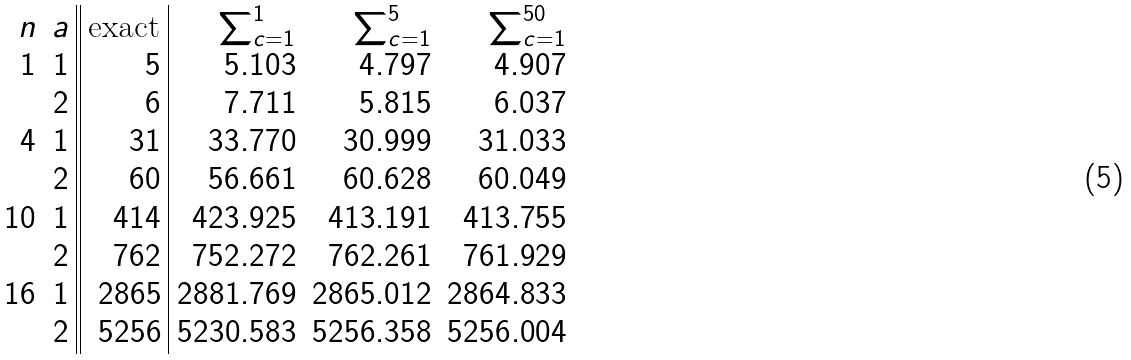Convert formula to latex. <formula><loc_0><loc_0><loc_500><loc_500>\begin{array} { r r | | r | r r r } n & a & \text {exact} & \sum _ { c = 1 } ^ { 1 } & \sum _ { c = 1 } ^ { 5 } & \sum _ { c = 1 } ^ { 5 0 } \\ 1 & 1 & 5 & 5 . 1 0 3 & 4 . 7 9 7 & 4 . 9 0 7 \\ & 2 & 6 & 7 . 7 1 1 & 5 . 8 1 5 & 6 . 0 3 7 \\ 4 & 1 & 3 1 & 3 3 . 7 7 0 & 3 0 . 9 9 9 & 3 1 . 0 3 3 \\ & 2 & 6 0 & 5 6 . 6 6 1 & 6 0 . 6 2 8 & 6 0 . 0 4 9 \\ 1 0 & 1 & 4 1 4 & 4 2 3 . 9 2 5 & 4 1 3 . 1 9 1 & 4 1 3 . 7 5 5 \\ & 2 & 7 6 2 & 7 5 2 . 2 7 2 & 7 6 2 . 2 6 1 & 7 6 1 . 9 2 9 \\ 1 6 & 1 & 2 8 6 5 & 2 8 8 1 . 7 6 9 & 2 8 6 5 . 0 1 2 & 2 8 6 4 . 8 3 3 \\ & 2 & 5 2 5 6 & 5 2 3 0 . 5 8 3 & 5 2 5 6 . 3 5 8 & 5 2 5 6 . 0 0 4 \\ \end{array}</formula> 